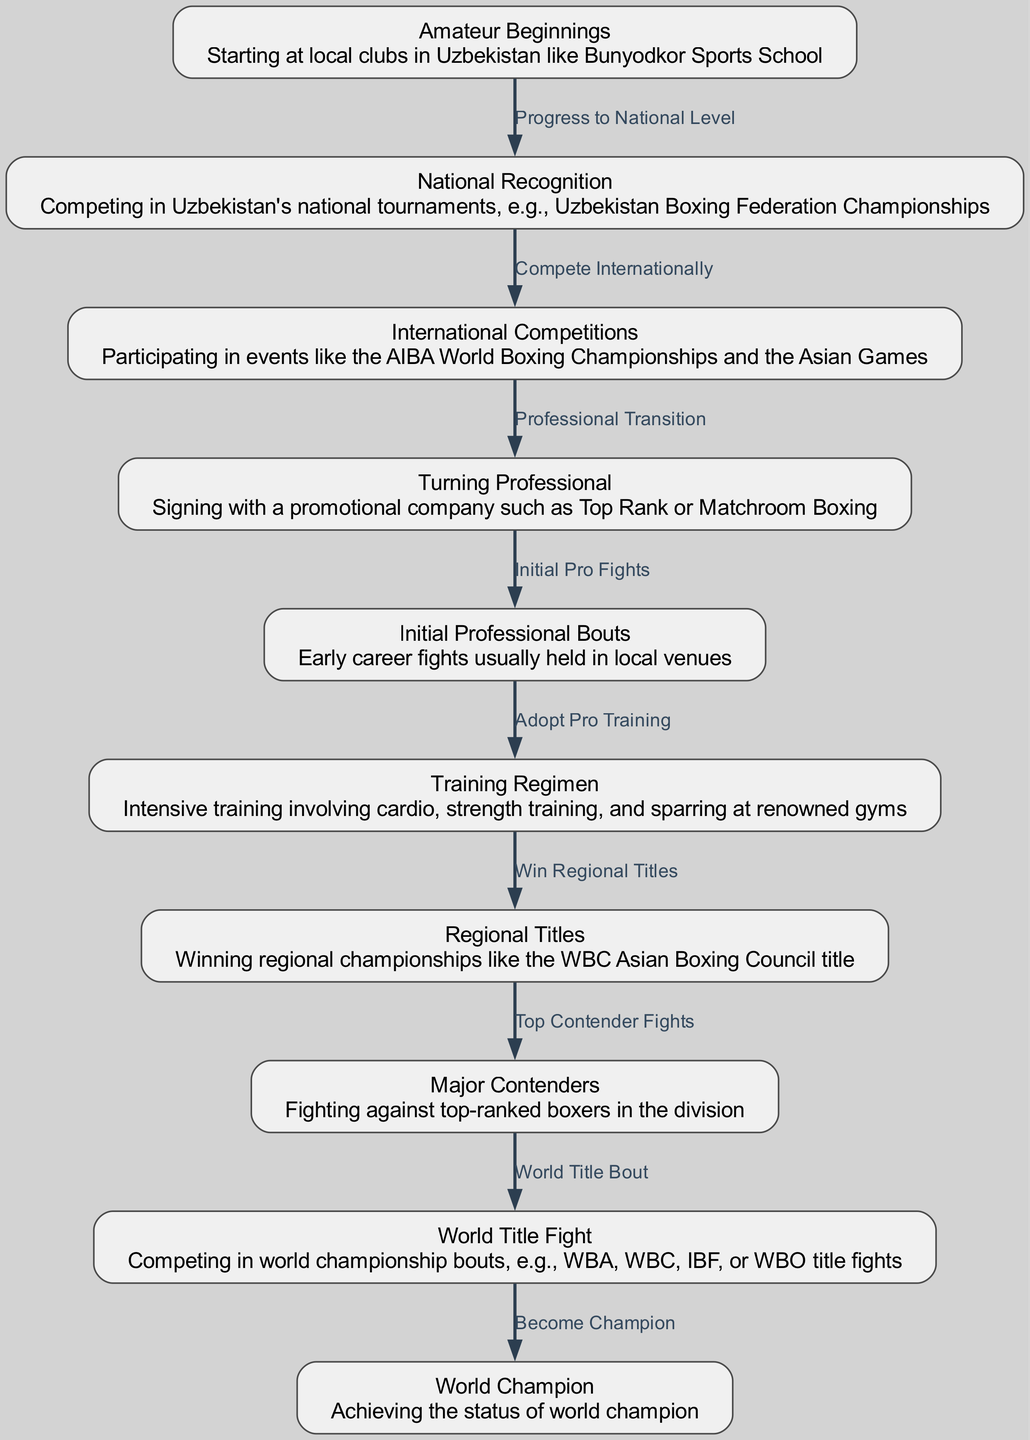What is the first node in the diagram? The diagram starts with "Amateur Beginnings" as the initial stage of a boxer's journey. This is depicted as the first node in the flowchart.
Answer: Amateur Beginnings How many nodes are in the diagram? By counting the key milestones described in the diagram, we find that there are ten distinct nodes illustrating the boxer’s journey from amateur beginnings to becoming a world champion.
Answer: 10 What is the last milestone before becoming a world champion? The last milestone before achieving the title of a world champion is "World Title Fight," which is illustrated as a key step that leads to the ultimate goal.
Answer: World Title Fight What edge connects "Turning Professional" to "Initial Professional Bouts"? The edge connecting these two nodes is labeled "Initial Pro Fights," indicating the transition from signing with a promotional company to the first professional fights.
Answer: Initial Pro Fights Which node follows "Major Contenders"? After "Major Contenders," the subsequent node in the flowchart is "World Title Fight," indicating that fights against top-ranked boxers precede the chance to compete for a world title.
Answer: World Title Fight How does a boxer progress from "International Competitions" to "Turning Professional"? The transition between these nodes is represented by the edge labeled "Professional Transition," indicating that after participating in international competitions, a boxer moves on to sign with a professional promotional company.
Answer: Professional Transition What training regimen is emphasized before winning regional titles? The diagram highlights "Training Regimen," which is vital for a boxer to develop necessary skills before competing for regional titles. It underscores the importance of appropriate training.
Answer: Training Regimen Which milestone is directly linked to the achievement of regional titles? "Win Regional Titles" is directly linked to the node "Training Regimen," suggesting that effective training is essential to secure regional championships.
Answer: Win Regional Titles Which edge specifies the relationship between "Initial Professional Bouts" and "Training Regimen"? The relationship is defined by the edge labeled "Adopt Pro Training," which indicates that following initial professional bouts, the boxer adopts a more rigorous training regimen.
Answer: Adopt Pro Training 